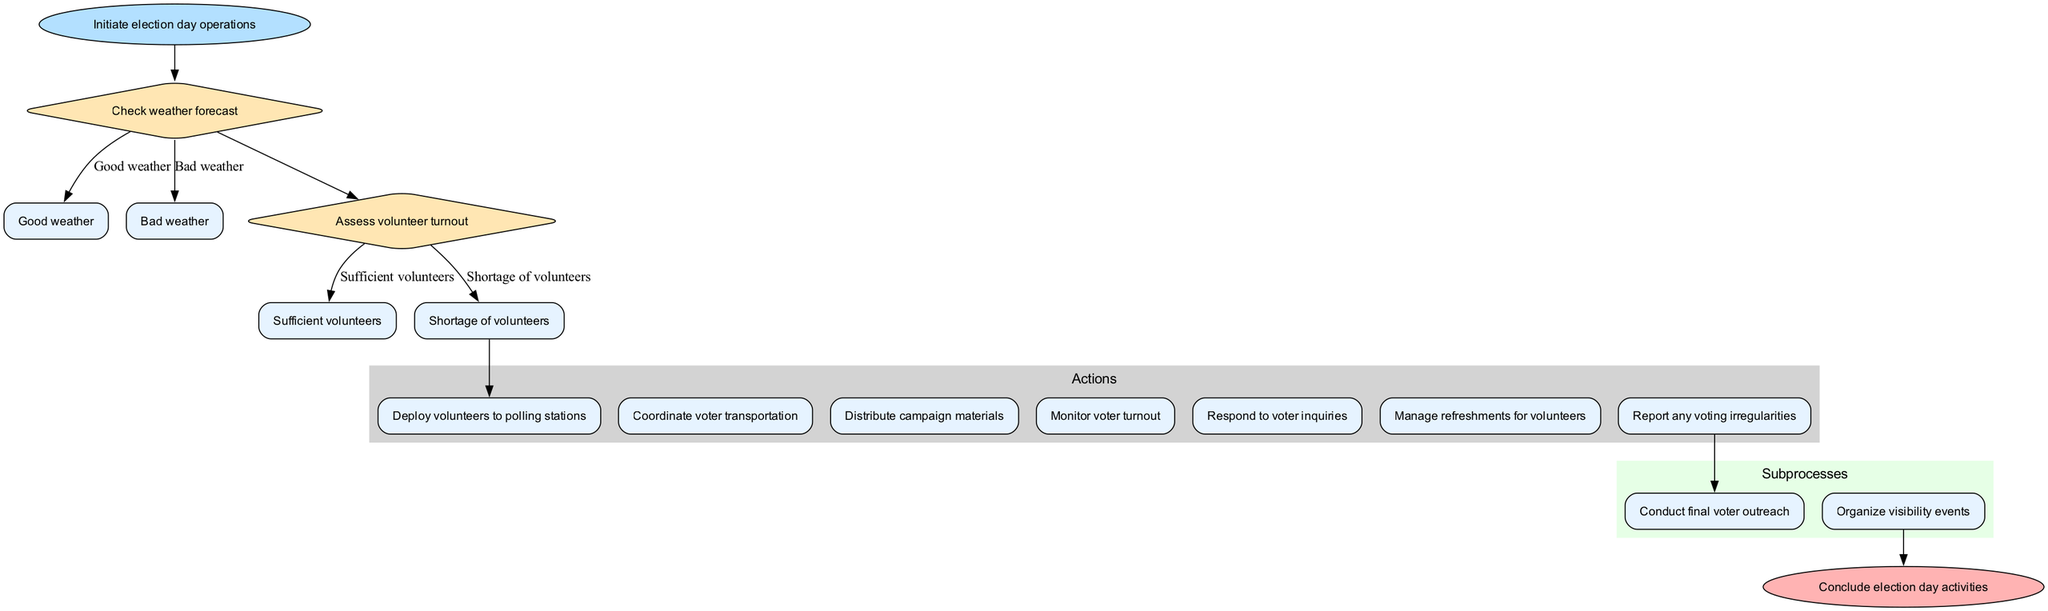What is the starting point of the diagram? The starting point is labeled as "Initiate election day operations," which is the first node of the flowchart.
Answer: Initiate election day operations How many decisions are made in the flow chart? There are two decisions made in the flowchart: "Check weather forecast" and "Assess volunteer turnout."
Answer: 2 What action is taken first after assessing volunteer turnout? After assessing volunteer turnout, if there are sufficient volunteers, the first action taken is "Deploy volunteers to polling stations."
Answer: Deploy volunteers to polling stations What happens if there is a shortage of volunteers? If there is a shortage of volunteers, the subsequent decision or action isn't explicitly shown in the diagram, but typically, one might explore alternatives or seek additional volunteers. Since the flow ends with the actions listed after the decision, we consider it leads into handling the shortage.
Answer: Handle shortage (implied) Which subprocess follows the action "Monitor voter turnout"? The subprocess that follows "Monitor voter turnout" is "Organize visibility events," as it directly connects to the end of the actions.
Answer: Organize visibility events If the weather is bad, what options are available? If the weather is bad, the subsequent nodes regarding actions are not shown, but the predefined options from the first decision indicate that actions would likely shift towards coordinating voter transportation and other logistics based on unsuitability for outdoor activities.
Answer: Adjust actions (implied) What action is aimed at dealing with potential voter issues? The action specifically aimed at dealing with potential voter issues is "Respond to voter inquiries." This indicates a direct line of communication for any issues arising during the voting process.
Answer: Respond to voter inquiries How does the flow end in the diagram? The flow ends with the node labeled "Conclude election day activities," which is connected from the last subprocess node.
Answer: Conclude election day activities 